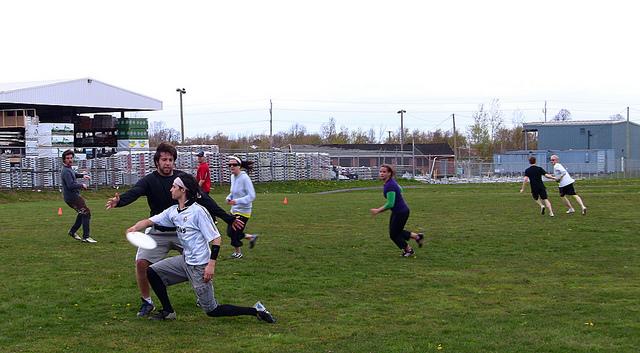What sport does this team play?
Write a very short answer. Frisbee. What's the weather like?
Write a very short answer. Cloudy. Are they on a field?
Write a very short answer. Yes. What sport are they playing?
Short answer required. Frisbee. 